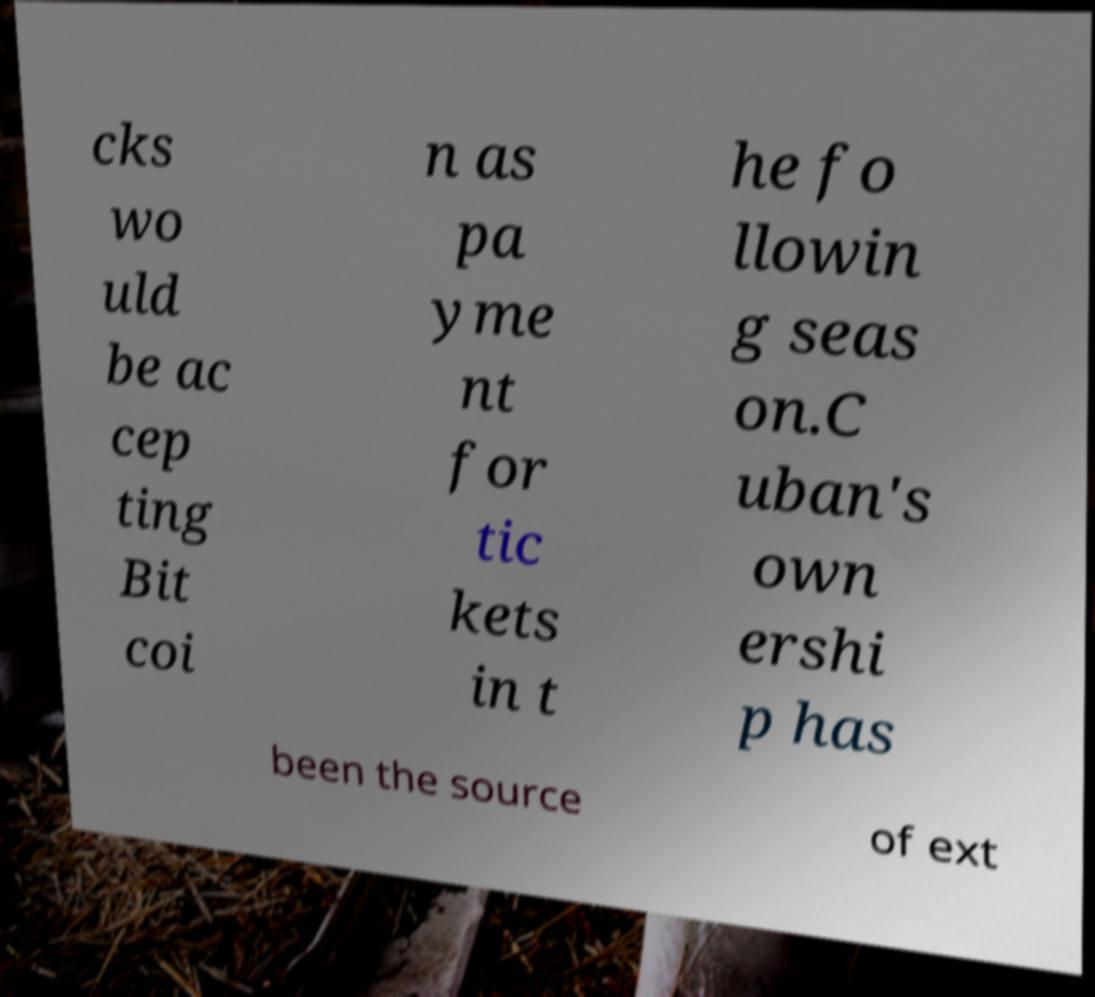Could you extract and type out the text from this image? cks wo uld be ac cep ting Bit coi n as pa yme nt for tic kets in t he fo llowin g seas on.C uban's own ershi p has been the source of ext 